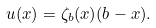<formula> <loc_0><loc_0><loc_500><loc_500>u ( x ) = \zeta _ { b } ( x ) ( b - x ) .</formula> 